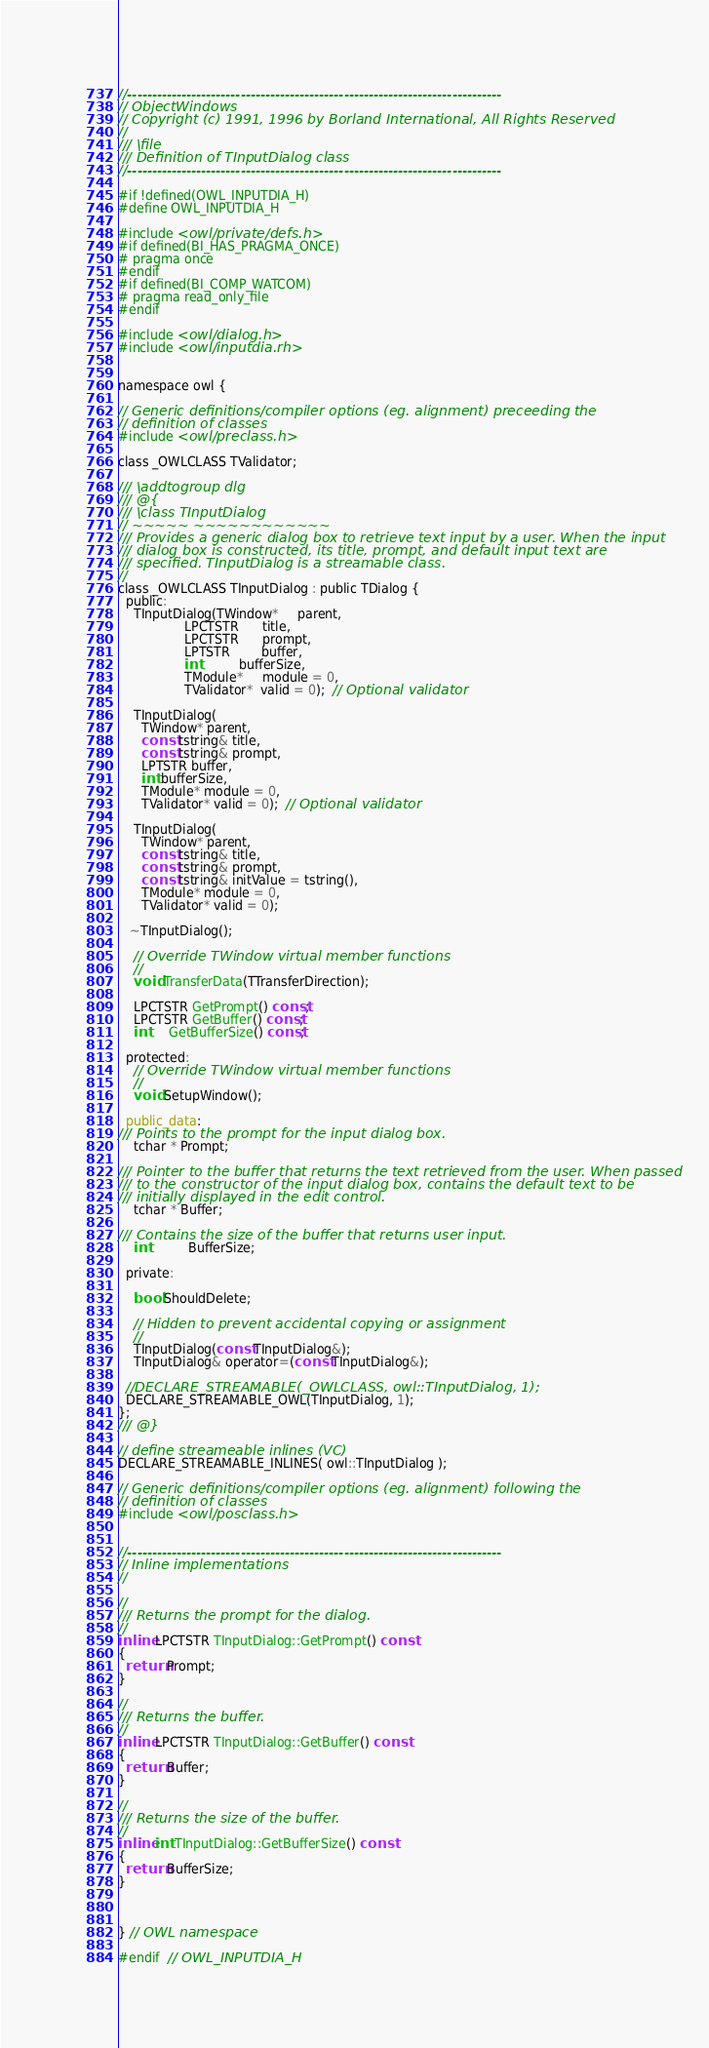Convert code to text. <code><loc_0><loc_0><loc_500><loc_500><_C_>//----------------------------------------------------------------------------
// ObjectWindows
// Copyright (c) 1991, 1996 by Borland International, All Rights Reserved
//
/// \file
/// Definition of TInputDialog class
//----------------------------------------------------------------------------

#if !defined(OWL_INPUTDIA_H)
#define OWL_INPUTDIA_H

#include <owl/private/defs.h>
#if defined(BI_HAS_PRAGMA_ONCE)
# pragma once
#endif
#if defined(BI_COMP_WATCOM)
# pragma read_only_file
#endif

#include <owl/dialog.h>
#include <owl/inputdia.rh>


namespace owl {

// Generic definitions/compiler options (eg. alignment) preceeding the
// definition of classes
#include <owl/preclass.h>

class _OWLCLASS TValidator;

/// \addtogroup dlg
/// @{
/// \class TInputDialog
// ~~~~~ ~~~~~~~~~~~~
/// Provides a generic dialog box to retrieve text input by a user. When the input
/// dialog box is constructed, its title, prompt, and default input text are
/// specified. TInputDialog is a streamable class.
//
class _OWLCLASS TInputDialog : public TDialog {
  public:
    TInputDialog(TWindow*     parent,
                 LPCTSTR      title,
                 LPCTSTR      prompt,
                 LPTSTR        buffer,
                 int          bufferSize,
                 TModule*     module = 0,
                 TValidator*  valid = 0);  // Optional validator

    TInputDialog(
      TWindow* parent,
      const tstring& title,
      const tstring& prompt,
      LPTSTR buffer,
      int bufferSize,
      TModule* module = 0,
      TValidator* valid = 0);  // Optional validator

    TInputDialog(
      TWindow* parent,
      const tstring& title,
      const tstring& prompt,
      const tstring& initValue = tstring(),
      TModule* module = 0,
      TValidator* valid = 0);

   ~TInputDialog();

    // Override TWindow virtual member functions
    //
    void TransferData(TTransferDirection);

    LPCTSTR GetPrompt() const;
    LPCTSTR GetBuffer() const;
    int     GetBufferSize() const;

  protected:
    // Override TWindow virtual member functions
    //
    void SetupWindow();

  public_data:
/// Points to the prompt for the input dialog box.
    tchar * Prompt;

/// Pointer to the buffer that returns the text retrieved from the user. When passed
/// to the constructor of the input dialog box, contains the default text to be
/// initially displayed in the edit control.
    tchar * Buffer;

/// Contains the size of the buffer that returns user input.
    int          BufferSize;

  private:

    bool ShouldDelete;

    // Hidden to prevent accidental copying or assignment
    //
    TInputDialog(const TInputDialog&);
    TInputDialog& operator=(const TInputDialog&);

  //DECLARE_STREAMABLE(_OWLCLASS, owl::TInputDialog, 1);
  DECLARE_STREAMABLE_OWL(TInputDialog, 1);
};
/// @}

// define streameable inlines (VC)
DECLARE_STREAMABLE_INLINES( owl::TInputDialog );

// Generic definitions/compiler options (eg. alignment) following the
// definition of classes
#include <owl/posclass.h>


//----------------------------------------------------------------------------
// Inline implementations
//

//
/// Returns the prompt for the dialog.
//
inline LPCTSTR TInputDialog::GetPrompt() const
{
  return Prompt;
}

//
/// Returns the buffer.
//
inline LPCTSTR TInputDialog::GetBuffer() const
{
  return Buffer;
}

//
/// Returns the size of the buffer.
//
inline int TInputDialog::GetBufferSize() const
{
  return BufferSize;
}



} // OWL namespace

#endif  // OWL_INPUTDIA_H
</code> 